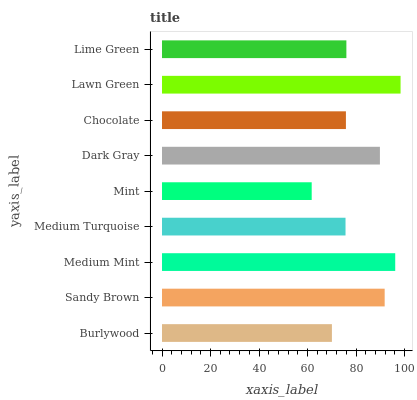Is Mint the minimum?
Answer yes or no. Yes. Is Lawn Green the maximum?
Answer yes or no. Yes. Is Sandy Brown the minimum?
Answer yes or no. No. Is Sandy Brown the maximum?
Answer yes or no. No. Is Sandy Brown greater than Burlywood?
Answer yes or no. Yes. Is Burlywood less than Sandy Brown?
Answer yes or no. Yes. Is Burlywood greater than Sandy Brown?
Answer yes or no. No. Is Sandy Brown less than Burlywood?
Answer yes or no. No. Is Lime Green the high median?
Answer yes or no. Yes. Is Lime Green the low median?
Answer yes or no. Yes. Is Medium Mint the high median?
Answer yes or no. No. Is Burlywood the low median?
Answer yes or no. No. 